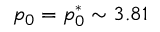<formula> <loc_0><loc_0><loc_500><loc_500>p _ { 0 } = p _ { 0 } ^ { * } \sim 3 . 8 1</formula> 